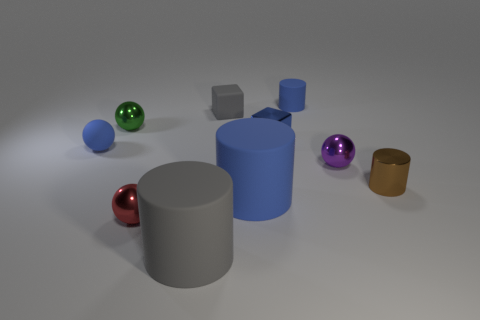Subtract all spheres. How many objects are left? 6 Subtract 0 cyan blocks. How many objects are left? 10 Subtract all tiny purple metallic objects. Subtract all brown cylinders. How many objects are left? 8 Add 1 tiny blue blocks. How many tiny blue blocks are left? 2 Add 8 blue matte cylinders. How many blue matte cylinders exist? 10 